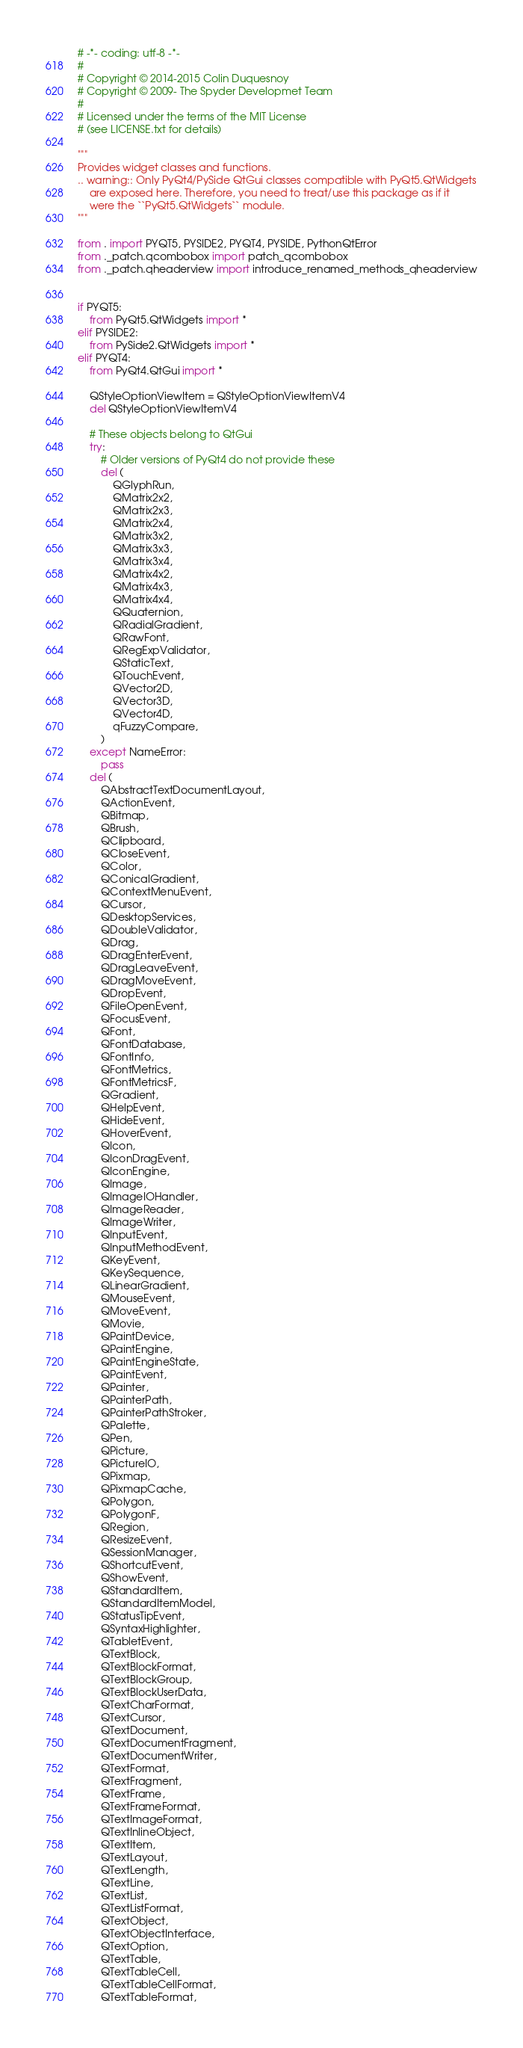Convert code to text. <code><loc_0><loc_0><loc_500><loc_500><_Python_># -*- coding: utf-8 -*-
#
# Copyright © 2014-2015 Colin Duquesnoy
# Copyright © 2009- The Spyder Developmet Team
#
# Licensed under the terms of the MIT License
# (see LICENSE.txt for details)

"""
Provides widget classes and functions.
.. warning:: Only PyQt4/PySide QtGui classes compatible with PyQt5.QtWidgets
    are exposed here. Therefore, you need to treat/use this package as if it
    were the ``PyQt5.QtWidgets`` module.
"""

from . import PYQT5, PYSIDE2, PYQT4, PYSIDE, PythonQtError
from ._patch.qcombobox import patch_qcombobox
from ._patch.qheaderview import introduce_renamed_methods_qheaderview


if PYQT5:
    from PyQt5.QtWidgets import *
elif PYSIDE2:
    from PySide2.QtWidgets import *
elif PYQT4:
    from PyQt4.QtGui import *

    QStyleOptionViewItem = QStyleOptionViewItemV4
    del QStyleOptionViewItemV4

    # These objects belong to QtGui
    try:
        # Older versions of PyQt4 do not provide these
        del (
            QGlyphRun,
            QMatrix2x2,
            QMatrix2x3,
            QMatrix2x4,
            QMatrix3x2,
            QMatrix3x3,
            QMatrix3x4,
            QMatrix4x2,
            QMatrix4x3,
            QMatrix4x4,
            QQuaternion,
            QRadialGradient,
            QRawFont,
            QRegExpValidator,
            QStaticText,
            QTouchEvent,
            QVector2D,
            QVector3D,
            QVector4D,
            qFuzzyCompare,
        )
    except NameError:
        pass
    del (
        QAbstractTextDocumentLayout,
        QActionEvent,
        QBitmap,
        QBrush,
        QClipboard,
        QCloseEvent,
        QColor,
        QConicalGradient,
        QContextMenuEvent,
        QCursor,
        QDesktopServices,
        QDoubleValidator,
        QDrag,
        QDragEnterEvent,
        QDragLeaveEvent,
        QDragMoveEvent,
        QDropEvent,
        QFileOpenEvent,
        QFocusEvent,
        QFont,
        QFontDatabase,
        QFontInfo,
        QFontMetrics,
        QFontMetricsF,
        QGradient,
        QHelpEvent,
        QHideEvent,
        QHoverEvent,
        QIcon,
        QIconDragEvent,
        QIconEngine,
        QImage,
        QImageIOHandler,
        QImageReader,
        QImageWriter,
        QInputEvent,
        QInputMethodEvent,
        QKeyEvent,
        QKeySequence,
        QLinearGradient,
        QMouseEvent,
        QMoveEvent,
        QMovie,
        QPaintDevice,
        QPaintEngine,
        QPaintEngineState,
        QPaintEvent,
        QPainter,
        QPainterPath,
        QPainterPathStroker,
        QPalette,
        QPen,
        QPicture,
        QPictureIO,
        QPixmap,
        QPixmapCache,
        QPolygon,
        QPolygonF,
        QRegion,
        QResizeEvent,
        QSessionManager,
        QShortcutEvent,
        QShowEvent,
        QStandardItem,
        QStandardItemModel,
        QStatusTipEvent,
        QSyntaxHighlighter,
        QTabletEvent,
        QTextBlock,
        QTextBlockFormat,
        QTextBlockGroup,
        QTextBlockUserData,
        QTextCharFormat,
        QTextCursor,
        QTextDocument,
        QTextDocumentFragment,
        QTextDocumentWriter,
        QTextFormat,
        QTextFragment,
        QTextFrame,
        QTextFrameFormat,
        QTextImageFormat,
        QTextInlineObject,
        QTextItem,
        QTextLayout,
        QTextLength,
        QTextLine,
        QTextList,
        QTextListFormat,
        QTextObject,
        QTextObjectInterface,
        QTextOption,
        QTextTable,
        QTextTableCell,
        QTextTableCellFormat,
        QTextTableFormat,</code> 